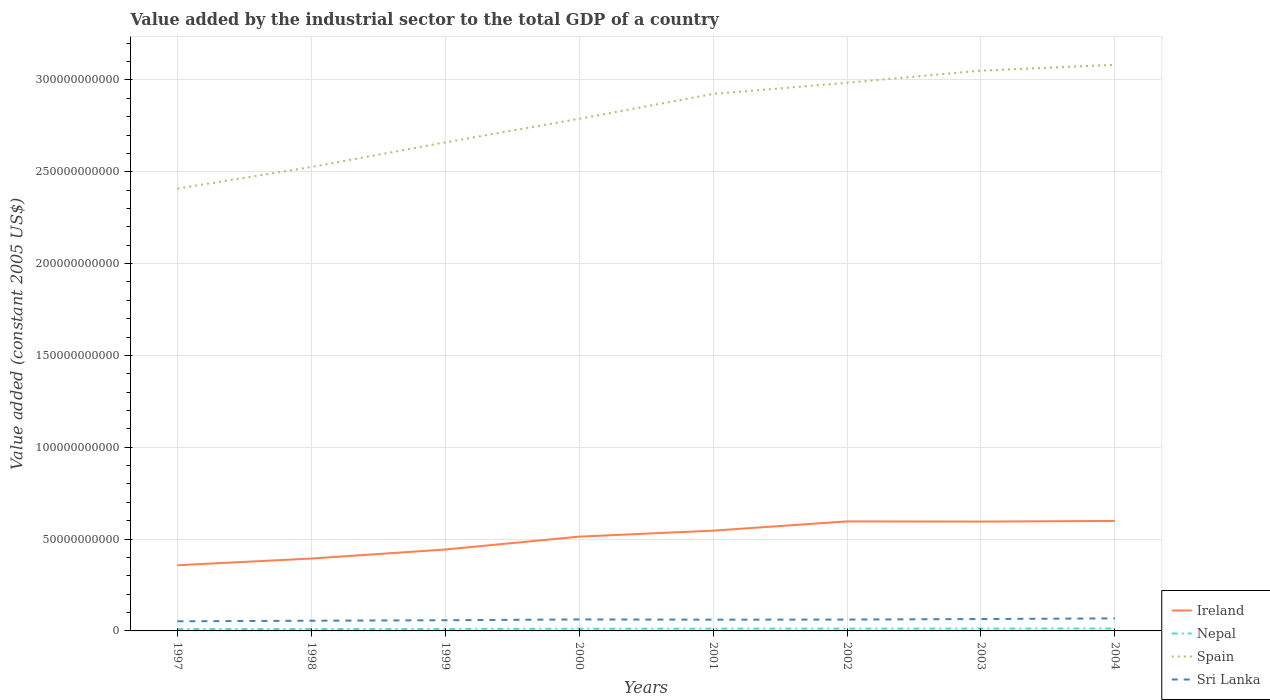How many different coloured lines are there?
Offer a terse response. 4. Does the line corresponding to Ireland intersect with the line corresponding to Spain?
Keep it short and to the point. No. Is the number of lines equal to the number of legend labels?
Your answer should be very brief. Yes. Across all years, what is the maximum value added by the industrial sector in Sri Lanka?
Give a very brief answer. 5.25e+09. In which year was the value added by the industrial sector in Sri Lanka maximum?
Make the answer very short. 1997. What is the total value added by the industrial sector in Nepal in the graph?
Offer a terse response. -9.19e+07. What is the difference between the highest and the second highest value added by the industrial sector in Ireland?
Keep it short and to the point. 2.41e+1. What is the difference between the highest and the lowest value added by the industrial sector in Ireland?
Provide a succinct answer. 5. How many lines are there?
Your response must be concise. 4. What is the difference between two consecutive major ticks on the Y-axis?
Your response must be concise. 5.00e+1. Are the values on the major ticks of Y-axis written in scientific E-notation?
Provide a short and direct response. No. Does the graph contain any zero values?
Your answer should be very brief. No. Does the graph contain grids?
Keep it short and to the point. Yes. How are the legend labels stacked?
Offer a very short reply. Vertical. What is the title of the graph?
Provide a short and direct response. Value added by the industrial sector to the total GDP of a country. What is the label or title of the X-axis?
Provide a short and direct response. Years. What is the label or title of the Y-axis?
Provide a short and direct response. Value added (constant 2005 US$). What is the Value added (constant 2005 US$) in Ireland in 1997?
Offer a terse response. 3.58e+1. What is the Value added (constant 2005 US$) in Nepal in 1997?
Your answer should be very brief. 1.01e+09. What is the Value added (constant 2005 US$) of Spain in 1997?
Provide a short and direct response. 2.41e+11. What is the Value added (constant 2005 US$) in Sri Lanka in 1997?
Your response must be concise. 5.25e+09. What is the Value added (constant 2005 US$) in Ireland in 1998?
Ensure brevity in your answer.  3.94e+1. What is the Value added (constant 2005 US$) in Nepal in 1998?
Provide a succinct answer. 1.04e+09. What is the Value added (constant 2005 US$) in Spain in 1998?
Your answer should be compact. 2.53e+11. What is the Value added (constant 2005 US$) of Sri Lanka in 1998?
Provide a succinct answer. 5.55e+09. What is the Value added (constant 2005 US$) of Ireland in 1999?
Your answer should be compact. 4.43e+1. What is the Value added (constant 2005 US$) of Nepal in 1999?
Offer a terse response. 1.10e+09. What is the Value added (constant 2005 US$) of Spain in 1999?
Provide a short and direct response. 2.66e+11. What is the Value added (constant 2005 US$) of Sri Lanka in 1999?
Offer a very short reply. 5.82e+09. What is the Value added (constant 2005 US$) in Ireland in 2000?
Offer a terse response. 5.13e+1. What is the Value added (constant 2005 US$) in Nepal in 2000?
Keep it short and to the point. 1.19e+09. What is the Value added (constant 2005 US$) in Spain in 2000?
Your response must be concise. 2.79e+11. What is the Value added (constant 2005 US$) of Sri Lanka in 2000?
Keep it short and to the point. 6.26e+09. What is the Value added (constant 2005 US$) in Ireland in 2001?
Your response must be concise. 5.46e+1. What is the Value added (constant 2005 US$) of Nepal in 2001?
Ensure brevity in your answer.  1.23e+09. What is the Value added (constant 2005 US$) of Spain in 2001?
Your answer should be very brief. 2.92e+11. What is the Value added (constant 2005 US$) of Sri Lanka in 2001?
Give a very brief answer. 6.13e+09. What is the Value added (constant 2005 US$) of Ireland in 2002?
Make the answer very short. 5.96e+1. What is the Value added (constant 2005 US$) in Nepal in 2002?
Offer a very short reply. 1.24e+09. What is the Value added (constant 2005 US$) in Spain in 2002?
Offer a terse response. 2.98e+11. What is the Value added (constant 2005 US$) in Sri Lanka in 2002?
Keep it short and to the point. 6.18e+09. What is the Value added (constant 2005 US$) in Ireland in 2003?
Your response must be concise. 5.95e+1. What is the Value added (constant 2005 US$) of Nepal in 2003?
Provide a succinct answer. 1.28e+09. What is the Value added (constant 2005 US$) in Spain in 2003?
Provide a succinct answer. 3.05e+11. What is the Value added (constant 2005 US$) in Sri Lanka in 2003?
Give a very brief answer. 6.47e+09. What is the Value added (constant 2005 US$) in Ireland in 2004?
Make the answer very short. 5.99e+1. What is the Value added (constant 2005 US$) in Nepal in 2004?
Provide a succinct answer. 1.30e+09. What is the Value added (constant 2005 US$) of Spain in 2004?
Your answer should be compact. 3.08e+11. What is the Value added (constant 2005 US$) in Sri Lanka in 2004?
Make the answer very short. 6.82e+09. Across all years, what is the maximum Value added (constant 2005 US$) of Ireland?
Keep it short and to the point. 5.99e+1. Across all years, what is the maximum Value added (constant 2005 US$) in Nepal?
Offer a terse response. 1.30e+09. Across all years, what is the maximum Value added (constant 2005 US$) in Spain?
Your answer should be compact. 3.08e+11. Across all years, what is the maximum Value added (constant 2005 US$) of Sri Lanka?
Offer a very short reply. 6.82e+09. Across all years, what is the minimum Value added (constant 2005 US$) in Ireland?
Provide a short and direct response. 3.58e+1. Across all years, what is the minimum Value added (constant 2005 US$) in Nepal?
Ensure brevity in your answer.  1.01e+09. Across all years, what is the minimum Value added (constant 2005 US$) in Spain?
Make the answer very short. 2.41e+11. Across all years, what is the minimum Value added (constant 2005 US$) of Sri Lanka?
Make the answer very short. 5.25e+09. What is the total Value added (constant 2005 US$) in Ireland in the graph?
Offer a terse response. 4.04e+11. What is the total Value added (constant 2005 US$) in Nepal in the graph?
Offer a very short reply. 9.40e+09. What is the total Value added (constant 2005 US$) of Spain in the graph?
Provide a short and direct response. 2.24e+12. What is the total Value added (constant 2005 US$) in Sri Lanka in the graph?
Your response must be concise. 4.85e+1. What is the difference between the Value added (constant 2005 US$) in Ireland in 1997 and that in 1998?
Give a very brief answer. -3.65e+09. What is the difference between the Value added (constant 2005 US$) in Nepal in 1997 and that in 1998?
Make the answer very short. -2.34e+07. What is the difference between the Value added (constant 2005 US$) in Spain in 1997 and that in 1998?
Provide a succinct answer. -1.18e+1. What is the difference between the Value added (constant 2005 US$) in Sri Lanka in 1997 and that in 1998?
Provide a succinct answer. -3.07e+08. What is the difference between the Value added (constant 2005 US$) of Ireland in 1997 and that in 1999?
Offer a very short reply. -8.56e+09. What is the difference between the Value added (constant 2005 US$) of Nepal in 1997 and that in 1999?
Provide a short and direct response. -8.55e+07. What is the difference between the Value added (constant 2005 US$) of Spain in 1997 and that in 1999?
Offer a very short reply. -2.52e+1. What is the difference between the Value added (constant 2005 US$) of Sri Lanka in 1997 and that in 1999?
Your answer should be very brief. -5.72e+08. What is the difference between the Value added (constant 2005 US$) of Ireland in 1997 and that in 2000?
Offer a very short reply. -1.56e+1. What is the difference between the Value added (constant 2005 US$) in Nepal in 1997 and that in 2000?
Give a very brief answer. -1.76e+08. What is the difference between the Value added (constant 2005 US$) of Spain in 1997 and that in 2000?
Make the answer very short. -3.80e+1. What is the difference between the Value added (constant 2005 US$) in Sri Lanka in 1997 and that in 2000?
Make the answer very short. -1.01e+09. What is the difference between the Value added (constant 2005 US$) in Ireland in 1997 and that in 2001?
Give a very brief answer. -1.88e+1. What is the difference between the Value added (constant 2005 US$) of Nepal in 1997 and that in 2001?
Your answer should be compact. -2.19e+08. What is the difference between the Value added (constant 2005 US$) of Spain in 1997 and that in 2001?
Make the answer very short. -5.16e+1. What is the difference between the Value added (constant 2005 US$) of Sri Lanka in 1997 and that in 2001?
Provide a short and direct response. -8.79e+08. What is the difference between the Value added (constant 2005 US$) of Ireland in 1997 and that in 2002?
Make the answer very short. -2.39e+1. What is the difference between the Value added (constant 2005 US$) in Nepal in 1997 and that in 2002?
Make the answer very short. -2.29e+08. What is the difference between the Value added (constant 2005 US$) of Spain in 1997 and that in 2002?
Provide a succinct answer. -5.76e+1. What is the difference between the Value added (constant 2005 US$) in Sri Lanka in 1997 and that in 2002?
Offer a very short reply. -9.38e+08. What is the difference between the Value added (constant 2005 US$) in Ireland in 1997 and that in 2003?
Provide a short and direct response. -2.38e+1. What is the difference between the Value added (constant 2005 US$) in Nepal in 1997 and that in 2003?
Ensure brevity in your answer.  -2.68e+08. What is the difference between the Value added (constant 2005 US$) of Spain in 1997 and that in 2003?
Your response must be concise. -6.42e+1. What is the difference between the Value added (constant 2005 US$) of Sri Lanka in 1997 and that in 2003?
Make the answer very short. -1.23e+09. What is the difference between the Value added (constant 2005 US$) in Ireland in 1997 and that in 2004?
Offer a very short reply. -2.41e+1. What is the difference between the Value added (constant 2005 US$) in Nepal in 1997 and that in 2004?
Make the answer very short. -2.86e+08. What is the difference between the Value added (constant 2005 US$) in Spain in 1997 and that in 2004?
Provide a succinct answer. -6.74e+1. What is the difference between the Value added (constant 2005 US$) of Sri Lanka in 1997 and that in 2004?
Your answer should be very brief. -1.58e+09. What is the difference between the Value added (constant 2005 US$) in Ireland in 1998 and that in 1999?
Give a very brief answer. -4.91e+09. What is the difference between the Value added (constant 2005 US$) in Nepal in 1998 and that in 1999?
Keep it short and to the point. -6.21e+07. What is the difference between the Value added (constant 2005 US$) of Spain in 1998 and that in 1999?
Provide a short and direct response. -1.34e+1. What is the difference between the Value added (constant 2005 US$) of Sri Lanka in 1998 and that in 1999?
Provide a short and direct response. -2.65e+08. What is the difference between the Value added (constant 2005 US$) of Ireland in 1998 and that in 2000?
Provide a succinct answer. -1.19e+1. What is the difference between the Value added (constant 2005 US$) of Nepal in 1998 and that in 2000?
Ensure brevity in your answer.  -1.52e+08. What is the difference between the Value added (constant 2005 US$) of Spain in 1998 and that in 2000?
Offer a very short reply. -2.63e+1. What is the difference between the Value added (constant 2005 US$) in Sri Lanka in 1998 and that in 2000?
Offer a terse response. -7.04e+08. What is the difference between the Value added (constant 2005 US$) in Ireland in 1998 and that in 2001?
Give a very brief answer. -1.52e+1. What is the difference between the Value added (constant 2005 US$) of Nepal in 1998 and that in 2001?
Keep it short and to the point. -1.95e+08. What is the difference between the Value added (constant 2005 US$) of Spain in 1998 and that in 2001?
Provide a short and direct response. -3.98e+1. What is the difference between the Value added (constant 2005 US$) of Sri Lanka in 1998 and that in 2001?
Give a very brief answer. -5.72e+08. What is the difference between the Value added (constant 2005 US$) in Ireland in 1998 and that in 2002?
Keep it short and to the point. -2.02e+1. What is the difference between the Value added (constant 2005 US$) of Nepal in 1998 and that in 2002?
Your response must be concise. -2.06e+08. What is the difference between the Value added (constant 2005 US$) in Spain in 1998 and that in 2002?
Give a very brief answer. -4.59e+1. What is the difference between the Value added (constant 2005 US$) in Sri Lanka in 1998 and that in 2002?
Keep it short and to the point. -6.30e+08. What is the difference between the Value added (constant 2005 US$) of Ireland in 1998 and that in 2003?
Provide a short and direct response. -2.01e+1. What is the difference between the Value added (constant 2005 US$) in Nepal in 1998 and that in 2003?
Make the answer very short. -2.44e+08. What is the difference between the Value added (constant 2005 US$) of Spain in 1998 and that in 2003?
Provide a short and direct response. -5.25e+1. What is the difference between the Value added (constant 2005 US$) in Sri Lanka in 1998 and that in 2003?
Offer a terse response. -9.19e+08. What is the difference between the Value added (constant 2005 US$) in Ireland in 1998 and that in 2004?
Offer a terse response. -2.05e+1. What is the difference between the Value added (constant 2005 US$) of Nepal in 1998 and that in 2004?
Your response must be concise. -2.63e+08. What is the difference between the Value added (constant 2005 US$) in Spain in 1998 and that in 2004?
Make the answer very short. -5.57e+1. What is the difference between the Value added (constant 2005 US$) of Sri Lanka in 1998 and that in 2004?
Ensure brevity in your answer.  -1.27e+09. What is the difference between the Value added (constant 2005 US$) of Ireland in 1999 and that in 2000?
Your response must be concise. -7.01e+09. What is the difference between the Value added (constant 2005 US$) of Nepal in 1999 and that in 2000?
Your response must be concise. -9.02e+07. What is the difference between the Value added (constant 2005 US$) in Spain in 1999 and that in 2000?
Your answer should be compact. -1.28e+1. What is the difference between the Value added (constant 2005 US$) in Sri Lanka in 1999 and that in 2000?
Your answer should be very brief. -4.39e+08. What is the difference between the Value added (constant 2005 US$) of Ireland in 1999 and that in 2001?
Give a very brief answer. -1.03e+1. What is the difference between the Value added (constant 2005 US$) of Nepal in 1999 and that in 2001?
Your answer should be very brief. -1.33e+08. What is the difference between the Value added (constant 2005 US$) of Spain in 1999 and that in 2001?
Offer a very short reply. -2.64e+1. What is the difference between the Value added (constant 2005 US$) in Sri Lanka in 1999 and that in 2001?
Provide a succinct answer. -3.07e+08. What is the difference between the Value added (constant 2005 US$) of Ireland in 1999 and that in 2002?
Provide a short and direct response. -1.53e+1. What is the difference between the Value added (constant 2005 US$) in Nepal in 1999 and that in 2002?
Make the answer very short. -1.44e+08. What is the difference between the Value added (constant 2005 US$) in Spain in 1999 and that in 2002?
Provide a short and direct response. -3.24e+1. What is the difference between the Value added (constant 2005 US$) in Sri Lanka in 1999 and that in 2002?
Your answer should be compact. -3.65e+08. What is the difference between the Value added (constant 2005 US$) in Ireland in 1999 and that in 2003?
Your answer should be compact. -1.52e+1. What is the difference between the Value added (constant 2005 US$) in Nepal in 1999 and that in 2003?
Ensure brevity in your answer.  -1.82e+08. What is the difference between the Value added (constant 2005 US$) in Spain in 1999 and that in 2003?
Your answer should be very brief. -3.90e+1. What is the difference between the Value added (constant 2005 US$) in Sri Lanka in 1999 and that in 2003?
Provide a succinct answer. -6.54e+08. What is the difference between the Value added (constant 2005 US$) of Ireland in 1999 and that in 2004?
Provide a short and direct response. -1.56e+1. What is the difference between the Value added (constant 2005 US$) of Nepal in 1999 and that in 2004?
Ensure brevity in your answer.  -2.00e+08. What is the difference between the Value added (constant 2005 US$) in Spain in 1999 and that in 2004?
Provide a succinct answer. -4.22e+1. What is the difference between the Value added (constant 2005 US$) in Sri Lanka in 1999 and that in 2004?
Your answer should be very brief. -1.00e+09. What is the difference between the Value added (constant 2005 US$) in Ireland in 2000 and that in 2001?
Provide a succinct answer. -3.26e+09. What is the difference between the Value added (constant 2005 US$) of Nepal in 2000 and that in 2001?
Your response must be concise. -4.28e+07. What is the difference between the Value added (constant 2005 US$) of Spain in 2000 and that in 2001?
Offer a terse response. -1.35e+1. What is the difference between the Value added (constant 2005 US$) in Sri Lanka in 2000 and that in 2001?
Make the answer very short. 1.32e+08. What is the difference between the Value added (constant 2005 US$) in Ireland in 2000 and that in 2002?
Provide a short and direct response. -8.30e+09. What is the difference between the Value added (constant 2005 US$) in Nepal in 2000 and that in 2002?
Provide a short and direct response. -5.35e+07. What is the difference between the Value added (constant 2005 US$) in Spain in 2000 and that in 2002?
Offer a very short reply. -1.96e+1. What is the difference between the Value added (constant 2005 US$) of Sri Lanka in 2000 and that in 2002?
Give a very brief answer. 7.37e+07. What is the difference between the Value added (constant 2005 US$) of Ireland in 2000 and that in 2003?
Ensure brevity in your answer.  -8.20e+09. What is the difference between the Value added (constant 2005 US$) of Nepal in 2000 and that in 2003?
Keep it short and to the point. -9.19e+07. What is the difference between the Value added (constant 2005 US$) of Spain in 2000 and that in 2003?
Ensure brevity in your answer.  -2.62e+1. What is the difference between the Value added (constant 2005 US$) of Sri Lanka in 2000 and that in 2003?
Ensure brevity in your answer.  -2.15e+08. What is the difference between the Value added (constant 2005 US$) in Ireland in 2000 and that in 2004?
Offer a very short reply. -8.55e+09. What is the difference between the Value added (constant 2005 US$) of Nepal in 2000 and that in 2004?
Offer a very short reply. -1.10e+08. What is the difference between the Value added (constant 2005 US$) in Spain in 2000 and that in 2004?
Provide a short and direct response. -2.94e+1. What is the difference between the Value added (constant 2005 US$) in Sri Lanka in 2000 and that in 2004?
Make the answer very short. -5.65e+08. What is the difference between the Value added (constant 2005 US$) in Ireland in 2001 and that in 2002?
Give a very brief answer. -5.04e+09. What is the difference between the Value added (constant 2005 US$) of Nepal in 2001 and that in 2002?
Ensure brevity in your answer.  -1.07e+07. What is the difference between the Value added (constant 2005 US$) of Spain in 2001 and that in 2002?
Keep it short and to the point. -6.08e+09. What is the difference between the Value added (constant 2005 US$) of Sri Lanka in 2001 and that in 2002?
Your answer should be compact. -5.86e+07. What is the difference between the Value added (constant 2005 US$) in Ireland in 2001 and that in 2003?
Give a very brief answer. -4.95e+09. What is the difference between the Value added (constant 2005 US$) of Nepal in 2001 and that in 2003?
Give a very brief answer. -4.91e+07. What is the difference between the Value added (constant 2005 US$) of Spain in 2001 and that in 2003?
Offer a terse response. -1.27e+1. What is the difference between the Value added (constant 2005 US$) in Sri Lanka in 2001 and that in 2003?
Provide a succinct answer. -3.47e+08. What is the difference between the Value added (constant 2005 US$) in Ireland in 2001 and that in 2004?
Offer a very short reply. -5.29e+09. What is the difference between the Value added (constant 2005 US$) of Nepal in 2001 and that in 2004?
Provide a short and direct response. -6.75e+07. What is the difference between the Value added (constant 2005 US$) of Spain in 2001 and that in 2004?
Ensure brevity in your answer.  -1.59e+1. What is the difference between the Value added (constant 2005 US$) in Sri Lanka in 2001 and that in 2004?
Your answer should be very brief. -6.97e+08. What is the difference between the Value added (constant 2005 US$) of Ireland in 2002 and that in 2003?
Keep it short and to the point. 9.68e+07. What is the difference between the Value added (constant 2005 US$) in Nepal in 2002 and that in 2003?
Ensure brevity in your answer.  -3.84e+07. What is the difference between the Value added (constant 2005 US$) in Spain in 2002 and that in 2003?
Provide a succinct answer. -6.59e+09. What is the difference between the Value added (constant 2005 US$) in Sri Lanka in 2002 and that in 2003?
Offer a terse response. -2.89e+08. What is the difference between the Value added (constant 2005 US$) in Ireland in 2002 and that in 2004?
Keep it short and to the point. -2.46e+08. What is the difference between the Value added (constant 2005 US$) of Nepal in 2002 and that in 2004?
Ensure brevity in your answer.  -5.68e+07. What is the difference between the Value added (constant 2005 US$) of Spain in 2002 and that in 2004?
Keep it short and to the point. -9.79e+09. What is the difference between the Value added (constant 2005 US$) of Sri Lanka in 2002 and that in 2004?
Provide a succinct answer. -6.39e+08. What is the difference between the Value added (constant 2005 US$) of Ireland in 2003 and that in 2004?
Your answer should be compact. -3.43e+08. What is the difference between the Value added (constant 2005 US$) in Nepal in 2003 and that in 2004?
Provide a succinct answer. -1.84e+07. What is the difference between the Value added (constant 2005 US$) of Spain in 2003 and that in 2004?
Give a very brief answer. -3.20e+09. What is the difference between the Value added (constant 2005 US$) in Sri Lanka in 2003 and that in 2004?
Ensure brevity in your answer.  -3.50e+08. What is the difference between the Value added (constant 2005 US$) in Ireland in 1997 and the Value added (constant 2005 US$) in Nepal in 1998?
Your response must be concise. 3.47e+1. What is the difference between the Value added (constant 2005 US$) of Ireland in 1997 and the Value added (constant 2005 US$) of Spain in 1998?
Your answer should be very brief. -2.17e+11. What is the difference between the Value added (constant 2005 US$) in Ireland in 1997 and the Value added (constant 2005 US$) in Sri Lanka in 1998?
Provide a short and direct response. 3.02e+1. What is the difference between the Value added (constant 2005 US$) of Nepal in 1997 and the Value added (constant 2005 US$) of Spain in 1998?
Ensure brevity in your answer.  -2.52e+11. What is the difference between the Value added (constant 2005 US$) of Nepal in 1997 and the Value added (constant 2005 US$) of Sri Lanka in 1998?
Your response must be concise. -4.54e+09. What is the difference between the Value added (constant 2005 US$) of Spain in 1997 and the Value added (constant 2005 US$) of Sri Lanka in 1998?
Your response must be concise. 2.35e+11. What is the difference between the Value added (constant 2005 US$) in Ireland in 1997 and the Value added (constant 2005 US$) in Nepal in 1999?
Ensure brevity in your answer.  3.47e+1. What is the difference between the Value added (constant 2005 US$) of Ireland in 1997 and the Value added (constant 2005 US$) of Spain in 1999?
Your answer should be compact. -2.30e+11. What is the difference between the Value added (constant 2005 US$) of Ireland in 1997 and the Value added (constant 2005 US$) of Sri Lanka in 1999?
Make the answer very short. 2.99e+1. What is the difference between the Value added (constant 2005 US$) of Nepal in 1997 and the Value added (constant 2005 US$) of Spain in 1999?
Give a very brief answer. -2.65e+11. What is the difference between the Value added (constant 2005 US$) in Nepal in 1997 and the Value added (constant 2005 US$) in Sri Lanka in 1999?
Offer a terse response. -4.81e+09. What is the difference between the Value added (constant 2005 US$) of Spain in 1997 and the Value added (constant 2005 US$) of Sri Lanka in 1999?
Offer a terse response. 2.35e+11. What is the difference between the Value added (constant 2005 US$) in Ireland in 1997 and the Value added (constant 2005 US$) in Nepal in 2000?
Give a very brief answer. 3.46e+1. What is the difference between the Value added (constant 2005 US$) in Ireland in 1997 and the Value added (constant 2005 US$) in Spain in 2000?
Make the answer very short. -2.43e+11. What is the difference between the Value added (constant 2005 US$) of Ireland in 1997 and the Value added (constant 2005 US$) of Sri Lanka in 2000?
Make the answer very short. 2.95e+1. What is the difference between the Value added (constant 2005 US$) in Nepal in 1997 and the Value added (constant 2005 US$) in Spain in 2000?
Your response must be concise. -2.78e+11. What is the difference between the Value added (constant 2005 US$) of Nepal in 1997 and the Value added (constant 2005 US$) of Sri Lanka in 2000?
Make the answer very short. -5.24e+09. What is the difference between the Value added (constant 2005 US$) in Spain in 1997 and the Value added (constant 2005 US$) in Sri Lanka in 2000?
Make the answer very short. 2.35e+11. What is the difference between the Value added (constant 2005 US$) in Ireland in 1997 and the Value added (constant 2005 US$) in Nepal in 2001?
Provide a succinct answer. 3.45e+1. What is the difference between the Value added (constant 2005 US$) in Ireland in 1997 and the Value added (constant 2005 US$) in Spain in 2001?
Give a very brief answer. -2.57e+11. What is the difference between the Value added (constant 2005 US$) of Ireland in 1997 and the Value added (constant 2005 US$) of Sri Lanka in 2001?
Keep it short and to the point. 2.96e+1. What is the difference between the Value added (constant 2005 US$) of Nepal in 1997 and the Value added (constant 2005 US$) of Spain in 2001?
Your answer should be compact. -2.91e+11. What is the difference between the Value added (constant 2005 US$) of Nepal in 1997 and the Value added (constant 2005 US$) of Sri Lanka in 2001?
Ensure brevity in your answer.  -5.11e+09. What is the difference between the Value added (constant 2005 US$) of Spain in 1997 and the Value added (constant 2005 US$) of Sri Lanka in 2001?
Ensure brevity in your answer.  2.35e+11. What is the difference between the Value added (constant 2005 US$) in Ireland in 1997 and the Value added (constant 2005 US$) in Nepal in 2002?
Keep it short and to the point. 3.45e+1. What is the difference between the Value added (constant 2005 US$) of Ireland in 1997 and the Value added (constant 2005 US$) of Spain in 2002?
Provide a short and direct response. -2.63e+11. What is the difference between the Value added (constant 2005 US$) in Ireland in 1997 and the Value added (constant 2005 US$) in Sri Lanka in 2002?
Provide a short and direct response. 2.96e+1. What is the difference between the Value added (constant 2005 US$) in Nepal in 1997 and the Value added (constant 2005 US$) in Spain in 2002?
Ensure brevity in your answer.  -2.97e+11. What is the difference between the Value added (constant 2005 US$) in Nepal in 1997 and the Value added (constant 2005 US$) in Sri Lanka in 2002?
Provide a succinct answer. -5.17e+09. What is the difference between the Value added (constant 2005 US$) in Spain in 1997 and the Value added (constant 2005 US$) in Sri Lanka in 2002?
Offer a very short reply. 2.35e+11. What is the difference between the Value added (constant 2005 US$) in Ireland in 1997 and the Value added (constant 2005 US$) in Nepal in 2003?
Your answer should be compact. 3.45e+1. What is the difference between the Value added (constant 2005 US$) in Ireland in 1997 and the Value added (constant 2005 US$) in Spain in 2003?
Give a very brief answer. -2.69e+11. What is the difference between the Value added (constant 2005 US$) in Ireland in 1997 and the Value added (constant 2005 US$) in Sri Lanka in 2003?
Provide a succinct answer. 2.93e+1. What is the difference between the Value added (constant 2005 US$) of Nepal in 1997 and the Value added (constant 2005 US$) of Spain in 2003?
Your answer should be very brief. -3.04e+11. What is the difference between the Value added (constant 2005 US$) in Nepal in 1997 and the Value added (constant 2005 US$) in Sri Lanka in 2003?
Your answer should be very brief. -5.46e+09. What is the difference between the Value added (constant 2005 US$) of Spain in 1997 and the Value added (constant 2005 US$) of Sri Lanka in 2003?
Provide a short and direct response. 2.34e+11. What is the difference between the Value added (constant 2005 US$) of Ireland in 1997 and the Value added (constant 2005 US$) of Nepal in 2004?
Your answer should be very brief. 3.45e+1. What is the difference between the Value added (constant 2005 US$) in Ireland in 1997 and the Value added (constant 2005 US$) in Spain in 2004?
Your answer should be compact. -2.72e+11. What is the difference between the Value added (constant 2005 US$) of Ireland in 1997 and the Value added (constant 2005 US$) of Sri Lanka in 2004?
Keep it short and to the point. 2.89e+1. What is the difference between the Value added (constant 2005 US$) in Nepal in 1997 and the Value added (constant 2005 US$) in Spain in 2004?
Offer a terse response. -3.07e+11. What is the difference between the Value added (constant 2005 US$) of Nepal in 1997 and the Value added (constant 2005 US$) of Sri Lanka in 2004?
Provide a succinct answer. -5.81e+09. What is the difference between the Value added (constant 2005 US$) in Spain in 1997 and the Value added (constant 2005 US$) in Sri Lanka in 2004?
Your response must be concise. 2.34e+11. What is the difference between the Value added (constant 2005 US$) of Ireland in 1998 and the Value added (constant 2005 US$) of Nepal in 1999?
Offer a very short reply. 3.83e+1. What is the difference between the Value added (constant 2005 US$) in Ireland in 1998 and the Value added (constant 2005 US$) in Spain in 1999?
Make the answer very short. -2.27e+11. What is the difference between the Value added (constant 2005 US$) of Ireland in 1998 and the Value added (constant 2005 US$) of Sri Lanka in 1999?
Your response must be concise. 3.36e+1. What is the difference between the Value added (constant 2005 US$) of Nepal in 1998 and the Value added (constant 2005 US$) of Spain in 1999?
Your response must be concise. -2.65e+11. What is the difference between the Value added (constant 2005 US$) of Nepal in 1998 and the Value added (constant 2005 US$) of Sri Lanka in 1999?
Offer a terse response. -4.78e+09. What is the difference between the Value added (constant 2005 US$) of Spain in 1998 and the Value added (constant 2005 US$) of Sri Lanka in 1999?
Your response must be concise. 2.47e+11. What is the difference between the Value added (constant 2005 US$) in Ireland in 1998 and the Value added (constant 2005 US$) in Nepal in 2000?
Your answer should be very brief. 3.82e+1. What is the difference between the Value added (constant 2005 US$) of Ireland in 1998 and the Value added (constant 2005 US$) of Spain in 2000?
Make the answer very short. -2.39e+11. What is the difference between the Value added (constant 2005 US$) in Ireland in 1998 and the Value added (constant 2005 US$) in Sri Lanka in 2000?
Your response must be concise. 3.32e+1. What is the difference between the Value added (constant 2005 US$) of Nepal in 1998 and the Value added (constant 2005 US$) of Spain in 2000?
Give a very brief answer. -2.78e+11. What is the difference between the Value added (constant 2005 US$) of Nepal in 1998 and the Value added (constant 2005 US$) of Sri Lanka in 2000?
Your response must be concise. -5.22e+09. What is the difference between the Value added (constant 2005 US$) in Spain in 1998 and the Value added (constant 2005 US$) in Sri Lanka in 2000?
Provide a succinct answer. 2.46e+11. What is the difference between the Value added (constant 2005 US$) in Ireland in 1998 and the Value added (constant 2005 US$) in Nepal in 2001?
Your answer should be very brief. 3.82e+1. What is the difference between the Value added (constant 2005 US$) of Ireland in 1998 and the Value added (constant 2005 US$) of Spain in 2001?
Provide a short and direct response. -2.53e+11. What is the difference between the Value added (constant 2005 US$) of Ireland in 1998 and the Value added (constant 2005 US$) of Sri Lanka in 2001?
Your answer should be very brief. 3.33e+1. What is the difference between the Value added (constant 2005 US$) in Nepal in 1998 and the Value added (constant 2005 US$) in Spain in 2001?
Make the answer very short. -2.91e+11. What is the difference between the Value added (constant 2005 US$) of Nepal in 1998 and the Value added (constant 2005 US$) of Sri Lanka in 2001?
Keep it short and to the point. -5.09e+09. What is the difference between the Value added (constant 2005 US$) of Spain in 1998 and the Value added (constant 2005 US$) of Sri Lanka in 2001?
Keep it short and to the point. 2.46e+11. What is the difference between the Value added (constant 2005 US$) in Ireland in 1998 and the Value added (constant 2005 US$) in Nepal in 2002?
Your response must be concise. 3.82e+1. What is the difference between the Value added (constant 2005 US$) of Ireland in 1998 and the Value added (constant 2005 US$) of Spain in 2002?
Offer a terse response. -2.59e+11. What is the difference between the Value added (constant 2005 US$) in Ireland in 1998 and the Value added (constant 2005 US$) in Sri Lanka in 2002?
Ensure brevity in your answer.  3.32e+1. What is the difference between the Value added (constant 2005 US$) of Nepal in 1998 and the Value added (constant 2005 US$) of Spain in 2002?
Keep it short and to the point. -2.97e+11. What is the difference between the Value added (constant 2005 US$) of Nepal in 1998 and the Value added (constant 2005 US$) of Sri Lanka in 2002?
Offer a very short reply. -5.15e+09. What is the difference between the Value added (constant 2005 US$) of Spain in 1998 and the Value added (constant 2005 US$) of Sri Lanka in 2002?
Provide a short and direct response. 2.46e+11. What is the difference between the Value added (constant 2005 US$) of Ireland in 1998 and the Value added (constant 2005 US$) of Nepal in 2003?
Provide a short and direct response. 3.81e+1. What is the difference between the Value added (constant 2005 US$) of Ireland in 1998 and the Value added (constant 2005 US$) of Spain in 2003?
Your answer should be very brief. -2.66e+11. What is the difference between the Value added (constant 2005 US$) in Ireland in 1998 and the Value added (constant 2005 US$) in Sri Lanka in 2003?
Give a very brief answer. 3.29e+1. What is the difference between the Value added (constant 2005 US$) of Nepal in 1998 and the Value added (constant 2005 US$) of Spain in 2003?
Ensure brevity in your answer.  -3.04e+11. What is the difference between the Value added (constant 2005 US$) of Nepal in 1998 and the Value added (constant 2005 US$) of Sri Lanka in 2003?
Provide a short and direct response. -5.44e+09. What is the difference between the Value added (constant 2005 US$) in Spain in 1998 and the Value added (constant 2005 US$) in Sri Lanka in 2003?
Your answer should be very brief. 2.46e+11. What is the difference between the Value added (constant 2005 US$) of Ireland in 1998 and the Value added (constant 2005 US$) of Nepal in 2004?
Ensure brevity in your answer.  3.81e+1. What is the difference between the Value added (constant 2005 US$) in Ireland in 1998 and the Value added (constant 2005 US$) in Spain in 2004?
Give a very brief answer. -2.69e+11. What is the difference between the Value added (constant 2005 US$) of Ireland in 1998 and the Value added (constant 2005 US$) of Sri Lanka in 2004?
Ensure brevity in your answer.  3.26e+1. What is the difference between the Value added (constant 2005 US$) of Nepal in 1998 and the Value added (constant 2005 US$) of Spain in 2004?
Your response must be concise. -3.07e+11. What is the difference between the Value added (constant 2005 US$) of Nepal in 1998 and the Value added (constant 2005 US$) of Sri Lanka in 2004?
Ensure brevity in your answer.  -5.79e+09. What is the difference between the Value added (constant 2005 US$) of Spain in 1998 and the Value added (constant 2005 US$) of Sri Lanka in 2004?
Offer a terse response. 2.46e+11. What is the difference between the Value added (constant 2005 US$) of Ireland in 1999 and the Value added (constant 2005 US$) of Nepal in 2000?
Provide a succinct answer. 4.31e+1. What is the difference between the Value added (constant 2005 US$) of Ireland in 1999 and the Value added (constant 2005 US$) of Spain in 2000?
Keep it short and to the point. -2.35e+11. What is the difference between the Value added (constant 2005 US$) of Ireland in 1999 and the Value added (constant 2005 US$) of Sri Lanka in 2000?
Your answer should be compact. 3.81e+1. What is the difference between the Value added (constant 2005 US$) of Nepal in 1999 and the Value added (constant 2005 US$) of Spain in 2000?
Ensure brevity in your answer.  -2.78e+11. What is the difference between the Value added (constant 2005 US$) in Nepal in 1999 and the Value added (constant 2005 US$) in Sri Lanka in 2000?
Ensure brevity in your answer.  -5.16e+09. What is the difference between the Value added (constant 2005 US$) of Spain in 1999 and the Value added (constant 2005 US$) of Sri Lanka in 2000?
Offer a terse response. 2.60e+11. What is the difference between the Value added (constant 2005 US$) in Ireland in 1999 and the Value added (constant 2005 US$) in Nepal in 2001?
Ensure brevity in your answer.  4.31e+1. What is the difference between the Value added (constant 2005 US$) of Ireland in 1999 and the Value added (constant 2005 US$) of Spain in 2001?
Offer a very short reply. -2.48e+11. What is the difference between the Value added (constant 2005 US$) in Ireland in 1999 and the Value added (constant 2005 US$) in Sri Lanka in 2001?
Your answer should be very brief. 3.82e+1. What is the difference between the Value added (constant 2005 US$) in Nepal in 1999 and the Value added (constant 2005 US$) in Spain in 2001?
Provide a succinct answer. -2.91e+11. What is the difference between the Value added (constant 2005 US$) of Nepal in 1999 and the Value added (constant 2005 US$) of Sri Lanka in 2001?
Provide a succinct answer. -5.03e+09. What is the difference between the Value added (constant 2005 US$) of Spain in 1999 and the Value added (constant 2005 US$) of Sri Lanka in 2001?
Provide a short and direct response. 2.60e+11. What is the difference between the Value added (constant 2005 US$) of Ireland in 1999 and the Value added (constant 2005 US$) of Nepal in 2002?
Provide a succinct answer. 4.31e+1. What is the difference between the Value added (constant 2005 US$) of Ireland in 1999 and the Value added (constant 2005 US$) of Spain in 2002?
Give a very brief answer. -2.54e+11. What is the difference between the Value added (constant 2005 US$) of Ireland in 1999 and the Value added (constant 2005 US$) of Sri Lanka in 2002?
Your answer should be very brief. 3.81e+1. What is the difference between the Value added (constant 2005 US$) of Nepal in 1999 and the Value added (constant 2005 US$) of Spain in 2002?
Offer a terse response. -2.97e+11. What is the difference between the Value added (constant 2005 US$) of Nepal in 1999 and the Value added (constant 2005 US$) of Sri Lanka in 2002?
Make the answer very short. -5.08e+09. What is the difference between the Value added (constant 2005 US$) of Spain in 1999 and the Value added (constant 2005 US$) of Sri Lanka in 2002?
Keep it short and to the point. 2.60e+11. What is the difference between the Value added (constant 2005 US$) of Ireland in 1999 and the Value added (constant 2005 US$) of Nepal in 2003?
Your answer should be very brief. 4.30e+1. What is the difference between the Value added (constant 2005 US$) in Ireland in 1999 and the Value added (constant 2005 US$) in Spain in 2003?
Ensure brevity in your answer.  -2.61e+11. What is the difference between the Value added (constant 2005 US$) in Ireland in 1999 and the Value added (constant 2005 US$) in Sri Lanka in 2003?
Your response must be concise. 3.79e+1. What is the difference between the Value added (constant 2005 US$) of Nepal in 1999 and the Value added (constant 2005 US$) of Spain in 2003?
Provide a short and direct response. -3.04e+11. What is the difference between the Value added (constant 2005 US$) in Nepal in 1999 and the Value added (constant 2005 US$) in Sri Lanka in 2003?
Your response must be concise. -5.37e+09. What is the difference between the Value added (constant 2005 US$) of Spain in 1999 and the Value added (constant 2005 US$) of Sri Lanka in 2003?
Your answer should be compact. 2.60e+11. What is the difference between the Value added (constant 2005 US$) in Ireland in 1999 and the Value added (constant 2005 US$) in Nepal in 2004?
Your answer should be very brief. 4.30e+1. What is the difference between the Value added (constant 2005 US$) of Ireland in 1999 and the Value added (constant 2005 US$) of Spain in 2004?
Your answer should be very brief. -2.64e+11. What is the difference between the Value added (constant 2005 US$) in Ireland in 1999 and the Value added (constant 2005 US$) in Sri Lanka in 2004?
Your answer should be very brief. 3.75e+1. What is the difference between the Value added (constant 2005 US$) of Nepal in 1999 and the Value added (constant 2005 US$) of Spain in 2004?
Provide a succinct answer. -3.07e+11. What is the difference between the Value added (constant 2005 US$) of Nepal in 1999 and the Value added (constant 2005 US$) of Sri Lanka in 2004?
Your answer should be compact. -5.72e+09. What is the difference between the Value added (constant 2005 US$) of Spain in 1999 and the Value added (constant 2005 US$) of Sri Lanka in 2004?
Offer a terse response. 2.59e+11. What is the difference between the Value added (constant 2005 US$) in Ireland in 2000 and the Value added (constant 2005 US$) in Nepal in 2001?
Provide a succinct answer. 5.01e+1. What is the difference between the Value added (constant 2005 US$) in Ireland in 2000 and the Value added (constant 2005 US$) in Spain in 2001?
Provide a succinct answer. -2.41e+11. What is the difference between the Value added (constant 2005 US$) in Ireland in 2000 and the Value added (constant 2005 US$) in Sri Lanka in 2001?
Your answer should be compact. 4.52e+1. What is the difference between the Value added (constant 2005 US$) of Nepal in 2000 and the Value added (constant 2005 US$) of Spain in 2001?
Your answer should be very brief. -2.91e+11. What is the difference between the Value added (constant 2005 US$) in Nepal in 2000 and the Value added (constant 2005 US$) in Sri Lanka in 2001?
Your answer should be compact. -4.94e+09. What is the difference between the Value added (constant 2005 US$) in Spain in 2000 and the Value added (constant 2005 US$) in Sri Lanka in 2001?
Make the answer very short. 2.73e+11. What is the difference between the Value added (constant 2005 US$) in Ireland in 2000 and the Value added (constant 2005 US$) in Nepal in 2002?
Make the answer very short. 5.01e+1. What is the difference between the Value added (constant 2005 US$) in Ireland in 2000 and the Value added (constant 2005 US$) in Spain in 2002?
Offer a terse response. -2.47e+11. What is the difference between the Value added (constant 2005 US$) in Ireland in 2000 and the Value added (constant 2005 US$) in Sri Lanka in 2002?
Make the answer very short. 4.52e+1. What is the difference between the Value added (constant 2005 US$) of Nepal in 2000 and the Value added (constant 2005 US$) of Spain in 2002?
Ensure brevity in your answer.  -2.97e+11. What is the difference between the Value added (constant 2005 US$) in Nepal in 2000 and the Value added (constant 2005 US$) in Sri Lanka in 2002?
Ensure brevity in your answer.  -4.99e+09. What is the difference between the Value added (constant 2005 US$) of Spain in 2000 and the Value added (constant 2005 US$) of Sri Lanka in 2002?
Keep it short and to the point. 2.73e+11. What is the difference between the Value added (constant 2005 US$) in Ireland in 2000 and the Value added (constant 2005 US$) in Nepal in 2003?
Your answer should be compact. 5.01e+1. What is the difference between the Value added (constant 2005 US$) in Ireland in 2000 and the Value added (constant 2005 US$) in Spain in 2003?
Your answer should be very brief. -2.54e+11. What is the difference between the Value added (constant 2005 US$) of Ireland in 2000 and the Value added (constant 2005 US$) of Sri Lanka in 2003?
Ensure brevity in your answer.  4.49e+1. What is the difference between the Value added (constant 2005 US$) in Nepal in 2000 and the Value added (constant 2005 US$) in Spain in 2003?
Offer a very short reply. -3.04e+11. What is the difference between the Value added (constant 2005 US$) in Nepal in 2000 and the Value added (constant 2005 US$) in Sri Lanka in 2003?
Give a very brief answer. -5.28e+09. What is the difference between the Value added (constant 2005 US$) of Spain in 2000 and the Value added (constant 2005 US$) of Sri Lanka in 2003?
Offer a very short reply. 2.72e+11. What is the difference between the Value added (constant 2005 US$) in Ireland in 2000 and the Value added (constant 2005 US$) in Nepal in 2004?
Make the answer very short. 5.00e+1. What is the difference between the Value added (constant 2005 US$) in Ireland in 2000 and the Value added (constant 2005 US$) in Spain in 2004?
Give a very brief answer. -2.57e+11. What is the difference between the Value added (constant 2005 US$) in Ireland in 2000 and the Value added (constant 2005 US$) in Sri Lanka in 2004?
Your response must be concise. 4.45e+1. What is the difference between the Value added (constant 2005 US$) in Nepal in 2000 and the Value added (constant 2005 US$) in Spain in 2004?
Your answer should be very brief. -3.07e+11. What is the difference between the Value added (constant 2005 US$) in Nepal in 2000 and the Value added (constant 2005 US$) in Sri Lanka in 2004?
Ensure brevity in your answer.  -5.63e+09. What is the difference between the Value added (constant 2005 US$) of Spain in 2000 and the Value added (constant 2005 US$) of Sri Lanka in 2004?
Provide a short and direct response. 2.72e+11. What is the difference between the Value added (constant 2005 US$) in Ireland in 2001 and the Value added (constant 2005 US$) in Nepal in 2002?
Offer a very short reply. 5.33e+1. What is the difference between the Value added (constant 2005 US$) in Ireland in 2001 and the Value added (constant 2005 US$) in Spain in 2002?
Offer a terse response. -2.44e+11. What is the difference between the Value added (constant 2005 US$) of Ireland in 2001 and the Value added (constant 2005 US$) of Sri Lanka in 2002?
Make the answer very short. 4.84e+1. What is the difference between the Value added (constant 2005 US$) of Nepal in 2001 and the Value added (constant 2005 US$) of Spain in 2002?
Keep it short and to the point. -2.97e+11. What is the difference between the Value added (constant 2005 US$) of Nepal in 2001 and the Value added (constant 2005 US$) of Sri Lanka in 2002?
Provide a short and direct response. -4.95e+09. What is the difference between the Value added (constant 2005 US$) of Spain in 2001 and the Value added (constant 2005 US$) of Sri Lanka in 2002?
Your answer should be compact. 2.86e+11. What is the difference between the Value added (constant 2005 US$) in Ireland in 2001 and the Value added (constant 2005 US$) in Nepal in 2003?
Offer a terse response. 5.33e+1. What is the difference between the Value added (constant 2005 US$) in Ireland in 2001 and the Value added (constant 2005 US$) in Spain in 2003?
Give a very brief answer. -2.50e+11. What is the difference between the Value added (constant 2005 US$) of Ireland in 2001 and the Value added (constant 2005 US$) of Sri Lanka in 2003?
Make the answer very short. 4.81e+1. What is the difference between the Value added (constant 2005 US$) of Nepal in 2001 and the Value added (constant 2005 US$) of Spain in 2003?
Provide a succinct answer. -3.04e+11. What is the difference between the Value added (constant 2005 US$) of Nepal in 2001 and the Value added (constant 2005 US$) of Sri Lanka in 2003?
Your response must be concise. -5.24e+09. What is the difference between the Value added (constant 2005 US$) in Spain in 2001 and the Value added (constant 2005 US$) in Sri Lanka in 2003?
Provide a succinct answer. 2.86e+11. What is the difference between the Value added (constant 2005 US$) in Ireland in 2001 and the Value added (constant 2005 US$) in Nepal in 2004?
Ensure brevity in your answer.  5.33e+1. What is the difference between the Value added (constant 2005 US$) in Ireland in 2001 and the Value added (constant 2005 US$) in Spain in 2004?
Provide a succinct answer. -2.54e+11. What is the difference between the Value added (constant 2005 US$) in Ireland in 2001 and the Value added (constant 2005 US$) in Sri Lanka in 2004?
Offer a very short reply. 4.78e+1. What is the difference between the Value added (constant 2005 US$) of Nepal in 2001 and the Value added (constant 2005 US$) of Spain in 2004?
Your answer should be compact. -3.07e+11. What is the difference between the Value added (constant 2005 US$) of Nepal in 2001 and the Value added (constant 2005 US$) of Sri Lanka in 2004?
Provide a short and direct response. -5.59e+09. What is the difference between the Value added (constant 2005 US$) in Spain in 2001 and the Value added (constant 2005 US$) in Sri Lanka in 2004?
Make the answer very short. 2.86e+11. What is the difference between the Value added (constant 2005 US$) of Ireland in 2002 and the Value added (constant 2005 US$) of Nepal in 2003?
Keep it short and to the point. 5.84e+1. What is the difference between the Value added (constant 2005 US$) of Ireland in 2002 and the Value added (constant 2005 US$) of Spain in 2003?
Provide a short and direct response. -2.45e+11. What is the difference between the Value added (constant 2005 US$) of Ireland in 2002 and the Value added (constant 2005 US$) of Sri Lanka in 2003?
Make the answer very short. 5.32e+1. What is the difference between the Value added (constant 2005 US$) in Nepal in 2002 and the Value added (constant 2005 US$) in Spain in 2003?
Provide a short and direct response. -3.04e+11. What is the difference between the Value added (constant 2005 US$) of Nepal in 2002 and the Value added (constant 2005 US$) of Sri Lanka in 2003?
Give a very brief answer. -5.23e+09. What is the difference between the Value added (constant 2005 US$) in Spain in 2002 and the Value added (constant 2005 US$) in Sri Lanka in 2003?
Your answer should be compact. 2.92e+11. What is the difference between the Value added (constant 2005 US$) in Ireland in 2002 and the Value added (constant 2005 US$) in Nepal in 2004?
Offer a very short reply. 5.83e+1. What is the difference between the Value added (constant 2005 US$) of Ireland in 2002 and the Value added (constant 2005 US$) of Spain in 2004?
Keep it short and to the point. -2.49e+11. What is the difference between the Value added (constant 2005 US$) in Ireland in 2002 and the Value added (constant 2005 US$) in Sri Lanka in 2004?
Offer a terse response. 5.28e+1. What is the difference between the Value added (constant 2005 US$) of Nepal in 2002 and the Value added (constant 2005 US$) of Spain in 2004?
Make the answer very short. -3.07e+11. What is the difference between the Value added (constant 2005 US$) of Nepal in 2002 and the Value added (constant 2005 US$) of Sri Lanka in 2004?
Offer a very short reply. -5.58e+09. What is the difference between the Value added (constant 2005 US$) of Spain in 2002 and the Value added (constant 2005 US$) of Sri Lanka in 2004?
Make the answer very short. 2.92e+11. What is the difference between the Value added (constant 2005 US$) of Ireland in 2003 and the Value added (constant 2005 US$) of Nepal in 2004?
Your answer should be very brief. 5.82e+1. What is the difference between the Value added (constant 2005 US$) in Ireland in 2003 and the Value added (constant 2005 US$) in Spain in 2004?
Your answer should be very brief. -2.49e+11. What is the difference between the Value added (constant 2005 US$) of Ireland in 2003 and the Value added (constant 2005 US$) of Sri Lanka in 2004?
Provide a succinct answer. 5.27e+1. What is the difference between the Value added (constant 2005 US$) of Nepal in 2003 and the Value added (constant 2005 US$) of Spain in 2004?
Make the answer very short. -3.07e+11. What is the difference between the Value added (constant 2005 US$) of Nepal in 2003 and the Value added (constant 2005 US$) of Sri Lanka in 2004?
Your response must be concise. -5.54e+09. What is the difference between the Value added (constant 2005 US$) of Spain in 2003 and the Value added (constant 2005 US$) of Sri Lanka in 2004?
Offer a terse response. 2.98e+11. What is the average Value added (constant 2005 US$) in Ireland per year?
Ensure brevity in your answer.  5.06e+1. What is the average Value added (constant 2005 US$) of Nepal per year?
Offer a very short reply. 1.17e+09. What is the average Value added (constant 2005 US$) in Spain per year?
Offer a very short reply. 2.80e+11. What is the average Value added (constant 2005 US$) in Sri Lanka per year?
Keep it short and to the point. 6.06e+09. In the year 1997, what is the difference between the Value added (constant 2005 US$) in Ireland and Value added (constant 2005 US$) in Nepal?
Ensure brevity in your answer.  3.47e+1. In the year 1997, what is the difference between the Value added (constant 2005 US$) in Ireland and Value added (constant 2005 US$) in Spain?
Provide a short and direct response. -2.05e+11. In the year 1997, what is the difference between the Value added (constant 2005 US$) in Ireland and Value added (constant 2005 US$) in Sri Lanka?
Your response must be concise. 3.05e+1. In the year 1997, what is the difference between the Value added (constant 2005 US$) of Nepal and Value added (constant 2005 US$) of Spain?
Make the answer very short. -2.40e+11. In the year 1997, what is the difference between the Value added (constant 2005 US$) in Nepal and Value added (constant 2005 US$) in Sri Lanka?
Make the answer very short. -4.23e+09. In the year 1997, what is the difference between the Value added (constant 2005 US$) of Spain and Value added (constant 2005 US$) of Sri Lanka?
Make the answer very short. 2.36e+11. In the year 1998, what is the difference between the Value added (constant 2005 US$) in Ireland and Value added (constant 2005 US$) in Nepal?
Make the answer very short. 3.84e+1. In the year 1998, what is the difference between the Value added (constant 2005 US$) of Ireland and Value added (constant 2005 US$) of Spain?
Provide a succinct answer. -2.13e+11. In the year 1998, what is the difference between the Value added (constant 2005 US$) in Ireland and Value added (constant 2005 US$) in Sri Lanka?
Keep it short and to the point. 3.39e+1. In the year 1998, what is the difference between the Value added (constant 2005 US$) of Nepal and Value added (constant 2005 US$) of Spain?
Your response must be concise. -2.52e+11. In the year 1998, what is the difference between the Value added (constant 2005 US$) of Nepal and Value added (constant 2005 US$) of Sri Lanka?
Offer a terse response. -4.52e+09. In the year 1998, what is the difference between the Value added (constant 2005 US$) of Spain and Value added (constant 2005 US$) of Sri Lanka?
Provide a succinct answer. 2.47e+11. In the year 1999, what is the difference between the Value added (constant 2005 US$) of Ireland and Value added (constant 2005 US$) of Nepal?
Offer a terse response. 4.32e+1. In the year 1999, what is the difference between the Value added (constant 2005 US$) in Ireland and Value added (constant 2005 US$) in Spain?
Provide a succinct answer. -2.22e+11. In the year 1999, what is the difference between the Value added (constant 2005 US$) of Ireland and Value added (constant 2005 US$) of Sri Lanka?
Provide a succinct answer. 3.85e+1. In the year 1999, what is the difference between the Value added (constant 2005 US$) of Nepal and Value added (constant 2005 US$) of Spain?
Provide a short and direct response. -2.65e+11. In the year 1999, what is the difference between the Value added (constant 2005 US$) of Nepal and Value added (constant 2005 US$) of Sri Lanka?
Your answer should be compact. -4.72e+09. In the year 1999, what is the difference between the Value added (constant 2005 US$) of Spain and Value added (constant 2005 US$) of Sri Lanka?
Provide a succinct answer. 2.60e+11. In the year 2000, what is the difference between the Value added (constant 2005 US$) of Ireland and Value added (constant 2005 US$) of Nepal?
Make the answer very short. 5.01e+1. In the year 2000, what is the difference between the Value added (constant 2005 US$) of Ireland and Value added (constant 2005 US$) of Spain?
Provide a short and direct response. -2.28e+11. In the year 2000, what is the difference between the Value added (constant 2005 US$) in Ireland and Value added (constant 2005 US$) in Sri Lanka?
Keep it short and to the point. 4.51e+1. In the year 2000, what is the difference between the Value added (constant 2005 US$) of Nepal and Value added (constant 2005 US$) of Spain?
Give a very brief answer. -2.78e+11. In the year 2000, what is the difference between the Value added (constant 2005 US$) in Nepal and Value added (constant 2005 US$) in Sri Lanka?
Provide a succinct answer. -5.07e+09. In the year 2000, what is the difference between the Value added (constant 2005 US$) of Spain and Value added (constant 2005 US$) of Sri Lanka?
Offer a terse response. 2.73e+11. In the year 2001, what is the difference between the Value added (constant 2005 US$) of Ireland and Value added (constant 2005 US$) of Nepal?
Make the answer very short. 5.34e+1. In the year 2001, what is the difference between the Value added (constant 2005 US$) of Ireland and Value added (constant 2005 US$) of Spain?
Ensure brevity in your answer.  -2.38e+11. In the year 2001, what is the difference between the Value added (constant 2005 US$) of Ireland and Value added (constant 2005 US$) of Sri Lanka?
Provide a short and direct response. 4.85e+1. In the year 2001, what is the difference between the Value added (constant 2005 US$) of Nepal and Value added (constant 2005 US$) of Spain?
Keep it short and to the point. -2.91e+11. In the year 2001, what is the difference between the Value added (constant 2005 US$) of Nepal and Value added (constant 2005 US$) of Sri Lanka?
Offer a terse response. -4.89e+09. In the year 2001, what is the difference between the Value added (constant 2005 US$) of Spain and Value added (constant 2005 US$) of Sri Lanka?
Your answer should be very brief. 2.86e+11. In the year 2002, what is the difference between the Value added (constant 2005 US$) of Ireland and Value added (constant 2005 US$) of Nepal?
Your answer should be compact. 5.84e+1. In the year 2002, what is the difference between the Value added (constant 2005 US$) in Ireland and Value added (constant 2005 US$) in Spain?
Your answer should be compact. -2.39e+11. In the year 2002, what is the difference between the Value added (constant 2005 US$) of Ireland and Value added (constant 2005 US$) of Sri Lanka?
Provide a succinct answer. 5.35e+1. In the year 2002, what is the difference between the Value added (constant 2005 US$) in Nepal and Value added (constant 2005 US$) in Spain?
Your answer should be very brief. -2.97e+11. In the year 2002, what is the difference between the Value added (constant 2005 US$) in Nepal and Value added (constant 2005 US$) in Sri Lanka?
Your response must be concise. -4.94e+09. In the year 2002, what is the difference between the Value added (constant 2005 US$) of Spain and Value added (constant 2005 US$) of Sri Lanka?
Your answer should be compact. 2.92e+11. In the year 2003, what is the difference between the Value added (constant 2005 US$) in Ireland and Value added (constant 2005 US$) in Nepal?
Offer a very short reply. 5.83e+1. In the year 2003, what is the difference between the Value added (constant 2005 US$) in Ireland and Value added (constant 2005 US$) in Spain?
Your response must be concise. -2.46e+11. In the year 2003, what is the difference between the Value added (constant 2005 US$) in Ireland and Value added (constant 2005 US$) in Sri Lanka?
Ensure brevity in your answer.  5.31e+1. In the year 2003, what is the difference between the Value added (constant 2005 US$) in Nepal and Value added (constant 2005 US$) in Spain?
Keep it short and to the point. -3.04e+11. In the year 2003, what is the difference between the Value added (constant 2005 US$) of Nepal and Value added (constant 2005 US$) of Sri Lanka?
Your answer should be compact. -5.19e+09. In the year 2003, what is the difference between the Value added (constant 2005 US$) of Spain and Value added (constant 2005 US$) of Sri Lanka?
Provide a succinct answer. 2.99e+11. In the year 2004, what is the difference between the Value added (constant 2005 US$) of Ireland and Value added (constant 2005 US$) of Nepal?
Offer a terse response. 5.86e+1. In the year 2004, what is the difference between the Value added (constant 2005 US$) in Ireland and Value added (constant 2005 US$) in Spain?
Your response must be concise. -2.48e+11. In the year 2004, what is the difference between the Value added (constant 2005 US$) of Ireland and Value added (constant 2005 US$) of Sri Lanka?
Give a very brief answer. 5.31e+1. In the year 2004, what is the difference between the Value added (constant 2005 US$) in Nepal and Value added (constant 2005 US$) in Spain?
Keep it short and to the point. -3.07e+11. In the year 2004, what is the difference between the Value added (constant 2005 US$) of Nepal and Value added (constant 2005 US$) of Sri Lanka?
Make the answer very short. -5.52e+09. In the year 2004, what is the difference between the Value added (constant 2005 US$) in Spain and Value added (constant 2005 US$) in Sri Lanka?
Ensure brevity in your answer.  3.01e+11. What is the ratio of the Value added (constant 2005 US$) in Ireland in 1997 to that in 1998?
Give a very brief answer. 0.91. What is the ratio of the Value added (constant 2005 US$) of Nepal in 1997 to that in 1998?
Offer a terse response. 0.98. What is the ratio of the Value added (constant 2005 US$) of Spain in 1997 to that in 1998?
Give a very brief answer. 0.95. What is the ratio of the Value added (constant 2005 US$) in Sri Lanka in 1997 to that in 1998?
Your answer should be compact. 0.94. What is the ratio of the Value added (constant 2005 US$) in Ireland in 1997 to that in 1999?
Ensure brevity in your answer.  0.81. What is the ratio of the Value added (constant 2005 US$) of Nepal in 1997 to that in 1999?
Give a very brief answer. 0.92. What is the ratio of the Value added (constant 2005 US$) of Spain in 1997 to that in 1999?
Provide a succinct answer. 0.91. What is the ratio of the Value added (constant 2005 US$) of Sri Lanka in 1997 to that in 1999?
Your response must be concise. 0.9. What is the ratio of the Value added (constant 2005 US$) of Ireland in 1997 to that in 2000?
Offer a terse response. 0.7. What is the ratio of the Value added (constant 2005 US$) of Nepal in 1997 to that in 2000?
Provide a short and direct response. 0.85. What is the ratio of the Value added (constant 2005 US$) of Spain in 1997 to that in 2000?
Make the answer very short. 0.86. What is the ratio of the Value added (constant 2005 US$) of Sri Lanka in 1997 to that in 2000?
Provide a short and direct response. 0.84. What is the ratio of the Value added (constant 2005 US$) of Ireland in 1997 to that in 2001?
Your response must be concise. 0.66. What is the ratio of the Value added (constant 2005 US$) of Nepal in 1997 to that in 2001?
Offer a terse response. 0.82. What is the ratio of the Value added (constant 2005 US$) of Spain in 1997 to that in 2001?
Provide a short and direct response. 0.82. What is the ratio of the Value added (constant 2005 US$) of Sri Lanka in 1997 to that in 2001?
Your answer should be very brief. 0.86. What is the ratio of the Value added (constant 2005 US$) of Ireland in 1997 to that in 2002?
Offer a terse response. 0.6. What is the ratio of the Value added (constant 2005 US$) of Nepal in 1997 to that in 2002?
Give a very brief answer. 0.82. What is the ratio of the Value added (constant 2005 US$) in Spain in 1997 to that in 2002?
Offer a very short reply. 0.81. What is the ratio of the Value added (constant 2005 US$) of Sri Lanka in 1997 to that in 2002?
Offer a terse response. 0.85. What is the ratio of the Value added (constant 2005 US$) in Ireland in 1997 to that in 2003?
Provide a short and direct response. 0.6. What is the ratio of the Value added (constant 2005 US$) of Nepal in 1997 to that in 2003?
Offer a very short reply. 0.79. What is the ratio of the Value added (constant 2005 US$) of Spain in 1997 to that in 2003?
Your answer should be very brief. 0.79. What is the ratio of the Value added (constant 2005 US$) of Sri Lanka in 1997 to that in 2003?
Make the answer very short. 0.81. What is the ratio of the Value added (constant 2005 US$) of Ireland in 1997 to that in 2004?
Ensure brevity in your answer.  0.6. What is the ratio of the Value added (constant 2005 US$) of Nepal in 1997 to that in 2004?
Your answer should be compact. 0.78. What is the ratio of the Value added (constant 2005 US$) of Spain in 1997 to that in 2004?
Offer a very short reply. 0.78. What is the ratio of the Value added (constant 2005 US$) in Sri Lanka in 1997 to that in 2004?
Ensure brevity in your answer.  0.77. What is the ratio of the Value added (constant 2005 US$) of Ireland in 1998 to that in 1999?
Provide a succinct answer. 0.89. What is the ratio of the Value added (constant 2005 US$) of Nepal in 1998 to that in 1999?
Give a very brief answer. 0.94. What is the ratio of the Value added (constant 2005 US$) in Spain in 1998 to that in 1999?
Your answer should be very brief. 0.95. What is the ratio of the Value added (constant 2005 US$) in Sri Lanka in 1998 to that in 1999?
Make the answer very short. 0.95. What is the ratio of the Value added (constant 2005 US$) of Ireland in 1998 to that in 2000?
Ensure brevity in your answer.  0.77. What is the ratio of the Value added (constant 2005 US$) of Nepal in 1998 to that in 2000?
Offer a very short reply. 0.87. What is the ratio of the Value added (constant 2005 US$) in Spain in 1998 to that in 2000?
Ensure brevity in your answer.  0.91. What is the ratio of the Value added (constant 2005 US$) in Sri Lanka in 1998 to that in 2000?
Keep it short and to the point. 0.89. What is the ratio of the Value added (constant 2005 US$) of Ireland in 1998 to that in 2001?
Your answer should be compact. 0.72. What is the ratio of the Value added (constant 2005 US$) of Nepal in 1998 to that in 2001?
Your answer should be very brief. 0.84. What is the ratio of the Value added (constant 2005 US$) in Spain in 1998 to that in 2001?
Give a very brief answer. 0.86. What is the ratio of the Value added (constant 2005 US$) in Sri Lanka in 1998 to that in 2001?
Provide a succinct answer. 0.91. What is the ratio of the Value added (constant 2005 US$) in Ireland in 1998 to that in 2002?
Provide a succinct answer. 0.66. What is the ratio of the Value added (constant 2005 US$) in Nepal in 1998 to that in 2002?
Offer a terse response. 0.83. What is the ratio of the Value added (constant 2005 US$) of Spain in 1998 to that in 2002?
Make the answer very short. 0.85. What is the ratio of the Value added (constant 2005 US$) of Sri Lanka in 1998 to that in 2002?
Your answer should be very brief. 0.9. What is the ratio of the Value added (constant 2005 US$) in Ireland in 1998 to that in 2003?
Your answer should be compact. 0.66. What is the ratio of the Value added (constant 2005 US$) of Nepal in 1998 to that in 2003?
Your response must be concise. 0.81. What is the ratio of the Value added (constant 2005 US$) in Spain in 1998 to that in 2003?
Make the answer very short. 0.83. What is the ratio of the Value added (constant 2005 US$) in Sri Lanka in 1998 to that in 2003?
Make the answer very short. 0.86. What is the ratio of the Value added (constant 2005 US$) of Ireland in 1998 to that in 2004?
Give a very brief answer. 0.66. What is the ratio of the Value added (constant 2005 US$) of Nepal in 1998 to that in 2004?
Give a very brief answer. 0.8. What is the ratio of the Value added (constant 2005 US$) in Spain in 1998 to that in 2004?
Offer a very short reply. 0.82. What is the ratio of the Value added (constant 2005 US$) of Sri Lanka in 1998 to that in 2004?
Provide a succinct answer. 0.81. What is the ratio of the Value added (constant 2005 US$) of Ireland in 1999 to that in 2000?
Offer a terse response. 0.86. What is the ratio of the Value added (constant 2005 US$) in Nepal in 1999 to that in 2000?
Keep it short and to the point. 0.92. What is the ratio of the Value added (constant 2005 US$) of Spain in 1999 to that in 2000?
Your response must be concise. 0.95. What is the ratio of the Value added (constant 2005 US$) in Sri Lanka in 1999 to that in 2000?
Offer a very short reply. 0.93. What is the ratio of the Value added (constant 2005 US$) of Ireland in 1999 to that in 2001?
Your response must be concise. 0.81. What is the ratio of the Value added (constant 2005 US$) in Nepal in 1999 to that in 2001?
Provide a succinct answer. 0.89. What is the ratio of the Value added (constant 2005 US$) in Spain in 1999 to that in 2001?
Keep it short and to the point. 0.91. What is the ratio of the Value added (constant 2005 US$) in Sri Lanka in 1999 to that in 2001?
Your response must be concise. 0.95. What is the ratio of the Value added (constant 2005 US$) of Ireland in 1999 to that in 2002?
Provide a short and direct response. 0.74. What is the ratio of the Value added (constant 2005 US$) of Nepal in 1999 to that in 2002?
Offer a very short reply. 0.88. What is the ratio of the Value added (constant 2005 US$) in Spain in 1999 to that in 2002?
Your response must be concise. 0.89. What is the ratio of the Value added (constant 2005 US$) in Sri Lanka in 1999 to that in 2002?
Provide a succinct answer. 0.94. What is the ratio of the Value added (constant 2005 US$) of Ireland in 1999 to that in 2003?
Your response must be concise. 0.74. What is the ratio of the Value added (constant 2005 US$) of Nepal in 1999 to that in 2003?
Your answer should be very brief. 0.86. What is the ratio of the Value added (constant 2005 US$) of Spain in 1999 to that in 2003?
Provide a short and direct response. 0.87. What is the ratio of the Value added (constant 2005 US$) of Sri Lanka in 1999 to that in 2003?
Ensure brevity in your answer.  0.9. What is the ratio of the Value added (constant 2005 US$) in Ireland in 1999 to that in 2004?
Your response must be concise. 0.74. What is the ratio of the Value added (constant 2005 US$) in Nepal in 1999 to that in 2004?
Provide a short and direct response. 0.85. What is the ratio of the Value added (constant 2005 US$) in Spain in 1999 to that in 2004?
Your answer should be very brief. 0.86. What is the ratio of the Value added (constant 2005 US$) in Sri Lanka in 1999 to that in 2004?
Your answer should be compact. 0.85. What is the ratio of the Value added (constant 2005 US$) of Ireland in 2000 to that in 2001?
Provide a succinct answer. 0.94. What is the ratio of the Value added (constant 2005 US$) in Nepal in 2000 to that in 2001?
Keep it short and to the point. 0.97. What is the ratio of the Value added (constant 2005 US$) of Spain in 2000 to that in 2001?
Ensure brevity in your answer.  0.95. What is the ratio of the Value added (constant 2005 US$) of Sri Lanka in 2000 to that in 2001?
Keep it short and to the point. 1.02. What is the ratio of the Value added (constant 2005 US$) of Ireland in 2000 to that in 2002?
Keep it short and to the point. 0.86. What is the ratio of the Value added (constant 2005 US$) of Nepal in 2000 to that in 2002?
Provide a short and direct response. 0.96. What is the ratio of the Value added (constant 2005 US$) of Spain in 2000 to that in 2002?
Provide a short and direct response. 0.93. What is the ratio of the Value added (constant 2005 US$) in Sri Lanka in 2000 to that in 2002?
Provide a short and direct response. 1.01. What is the ratio of the Value added (constant 2005 US$) in Ireland in 2000 to that in 2003?
Your response must be concise. 0.86. What is the ratio of the Value added (constant 2005 US$) of Nepal in 2000 to that in 2003?
Your answer should be very brief. 0.93. What is the ratio of the Value added (constant 2005 US$) of Spain in 2000 to that in 2003?
Your answer should be very brief. 0.91. What is the ratio of the Value added (constant 2005 US$) in Sri Lanka in 2000 to that in 2003?
Your answer should be compact. 0.97. What is the ratio of the Value added (constant 2005 US$) of Ireland in 2000 to that in 2004?
Ensure brevity in your answer.  0.86. What is the ratio of the Value added (constant 2005 US$) in Nepal in 2000 to that in 2004?
Your answer should be compact. 0.92. What is the ratio of the Value added (constant 2005 US$) of Spain in 2000 to that in 2004?
Keep it short and to the point. 0.9. What is the ratio of the Value added (constant 2005 US$) of Sri Lanka in 2000 to that in 2004?
Offer a very short reply. 0.92. What is the ratio of the Value added (constant 2005 US$) of Ireland in 2001 to that in 2002?
Offer a very short reply. 0.92. What is the ratio of the Value added (constant 2005 US$) in Spain in 2001 to that in 2002?
Give a very brief answer. 0.98. What is the ratio of the Value added (constant 2005 US$) of Ireland in 2001 to that in 2003?
Make the answer very short. 0.92. What is the ratio of the Value added (constant 2005 US$) in Nepal in 2001 to that in 2003?
Make the answer very short. 0.96. What is the ratio of the Value added (constant 2005 US$) in Spain in 2001 to that in 2003?
Keep it short and to the point. 0.96. What is the ratio of the Value added (constant 2005 US$) in Sri Lanka in 2001 to that in 2003?
Provide a succinct answer. 0.95. What is the ratio of the Value added (constant 2005 US$) in Ireland in 2001 to that in 2004?
Your response must be concise. 0.91. What is the ratio of the Value added (constant 2005 US$) of Nepal in 2001 to that in 2004?
Give a very brief answer. 0.95. What is the ratio of the Value added (constant 2005 US$) of Spain in 2001 to that in 2004?
Offer a very short reply. 0.95. What is the ratio of the Value added (constant 2005 US$) of Sri Lanka in 2001 to that in 2004?
Provide a short and direct response. 0.9. What is the ratio of the Value added (constant 2005 US$) in Ireland in 2002 to that in 2003?
Offer a terse response. 1. What is the ratio of the Value added (constant 2005 US$) in Spain in 2002 to that in 2003?
Offer a very short reply. 0.98. What is the ratio of the Value added (constant 2005 US$) of Sri Lanka in 2002 to that in 2003?
Ensure brevity in your answer.  0.96. What is the ratio of the Value added (constant 2005 US$) of Ireland in 2002 to that in 2004?
Give a very brief answer. 1. What is the ratio of the Value added (constant 2005 US$) in Nepal in 2002 to that in 2004?
Provide a short and direct response. 0.96. What is the ratio of the Value added (constant 2005 US$) of Spain in 2002 to that in 2004?
Your response must be concise. 0.97. What is the ratio of the Value added (constant 2005 US$) of Sri Lanka in 2002 to that in 2004?
Offer a terse response. 0.91. What is the ratio of the Value added (constant 2005 US$) of Nepal in 2003 to that in 2004?
Provide a succinct answer. 0.99. What is the ratio of the Value added (constant 2005 US$) in Sri Lanka in 2003 to that in 2004?
Your response must be concise. 0.95. What is the difference between the highest and the second highest Value added (constant 2005 US$) in Ireland?
Your response must be concise. 2.46e+08. What is the difference between the highest and the second highest Value added (constant 2005 US$) of Nepal?
Make the answer very short. 1.84e+07. What is the difference between the highest and the second highest Value added (constant 2005 US$) of Spain?
Ensure brevity in your answer.  3.20e+09. What is the difference between the highest and the second highest Value added (constant 2005 US$) of Sri Lanka?
Offer a terse response. 3.50e+08. What is the difference between the highest and the lowest Value added (constant 2005 US$) of Ireland?
Your answer should be very brief. 2.41e+1. What is the difference between the highest and the lowest Value added (constant 2005 US$) of Nepal?
Your response must be concise. 2.86e+08. What is the difference between the highest and the lowest Value added (constant 2005 US$) in Spain?
Your answer should be compact. 6.74e+1. What is the difference between the highest and the lowest Value added (constant 2005 US$) in Sri Lanka?
Offer a very short reply. 1.58e+09. 